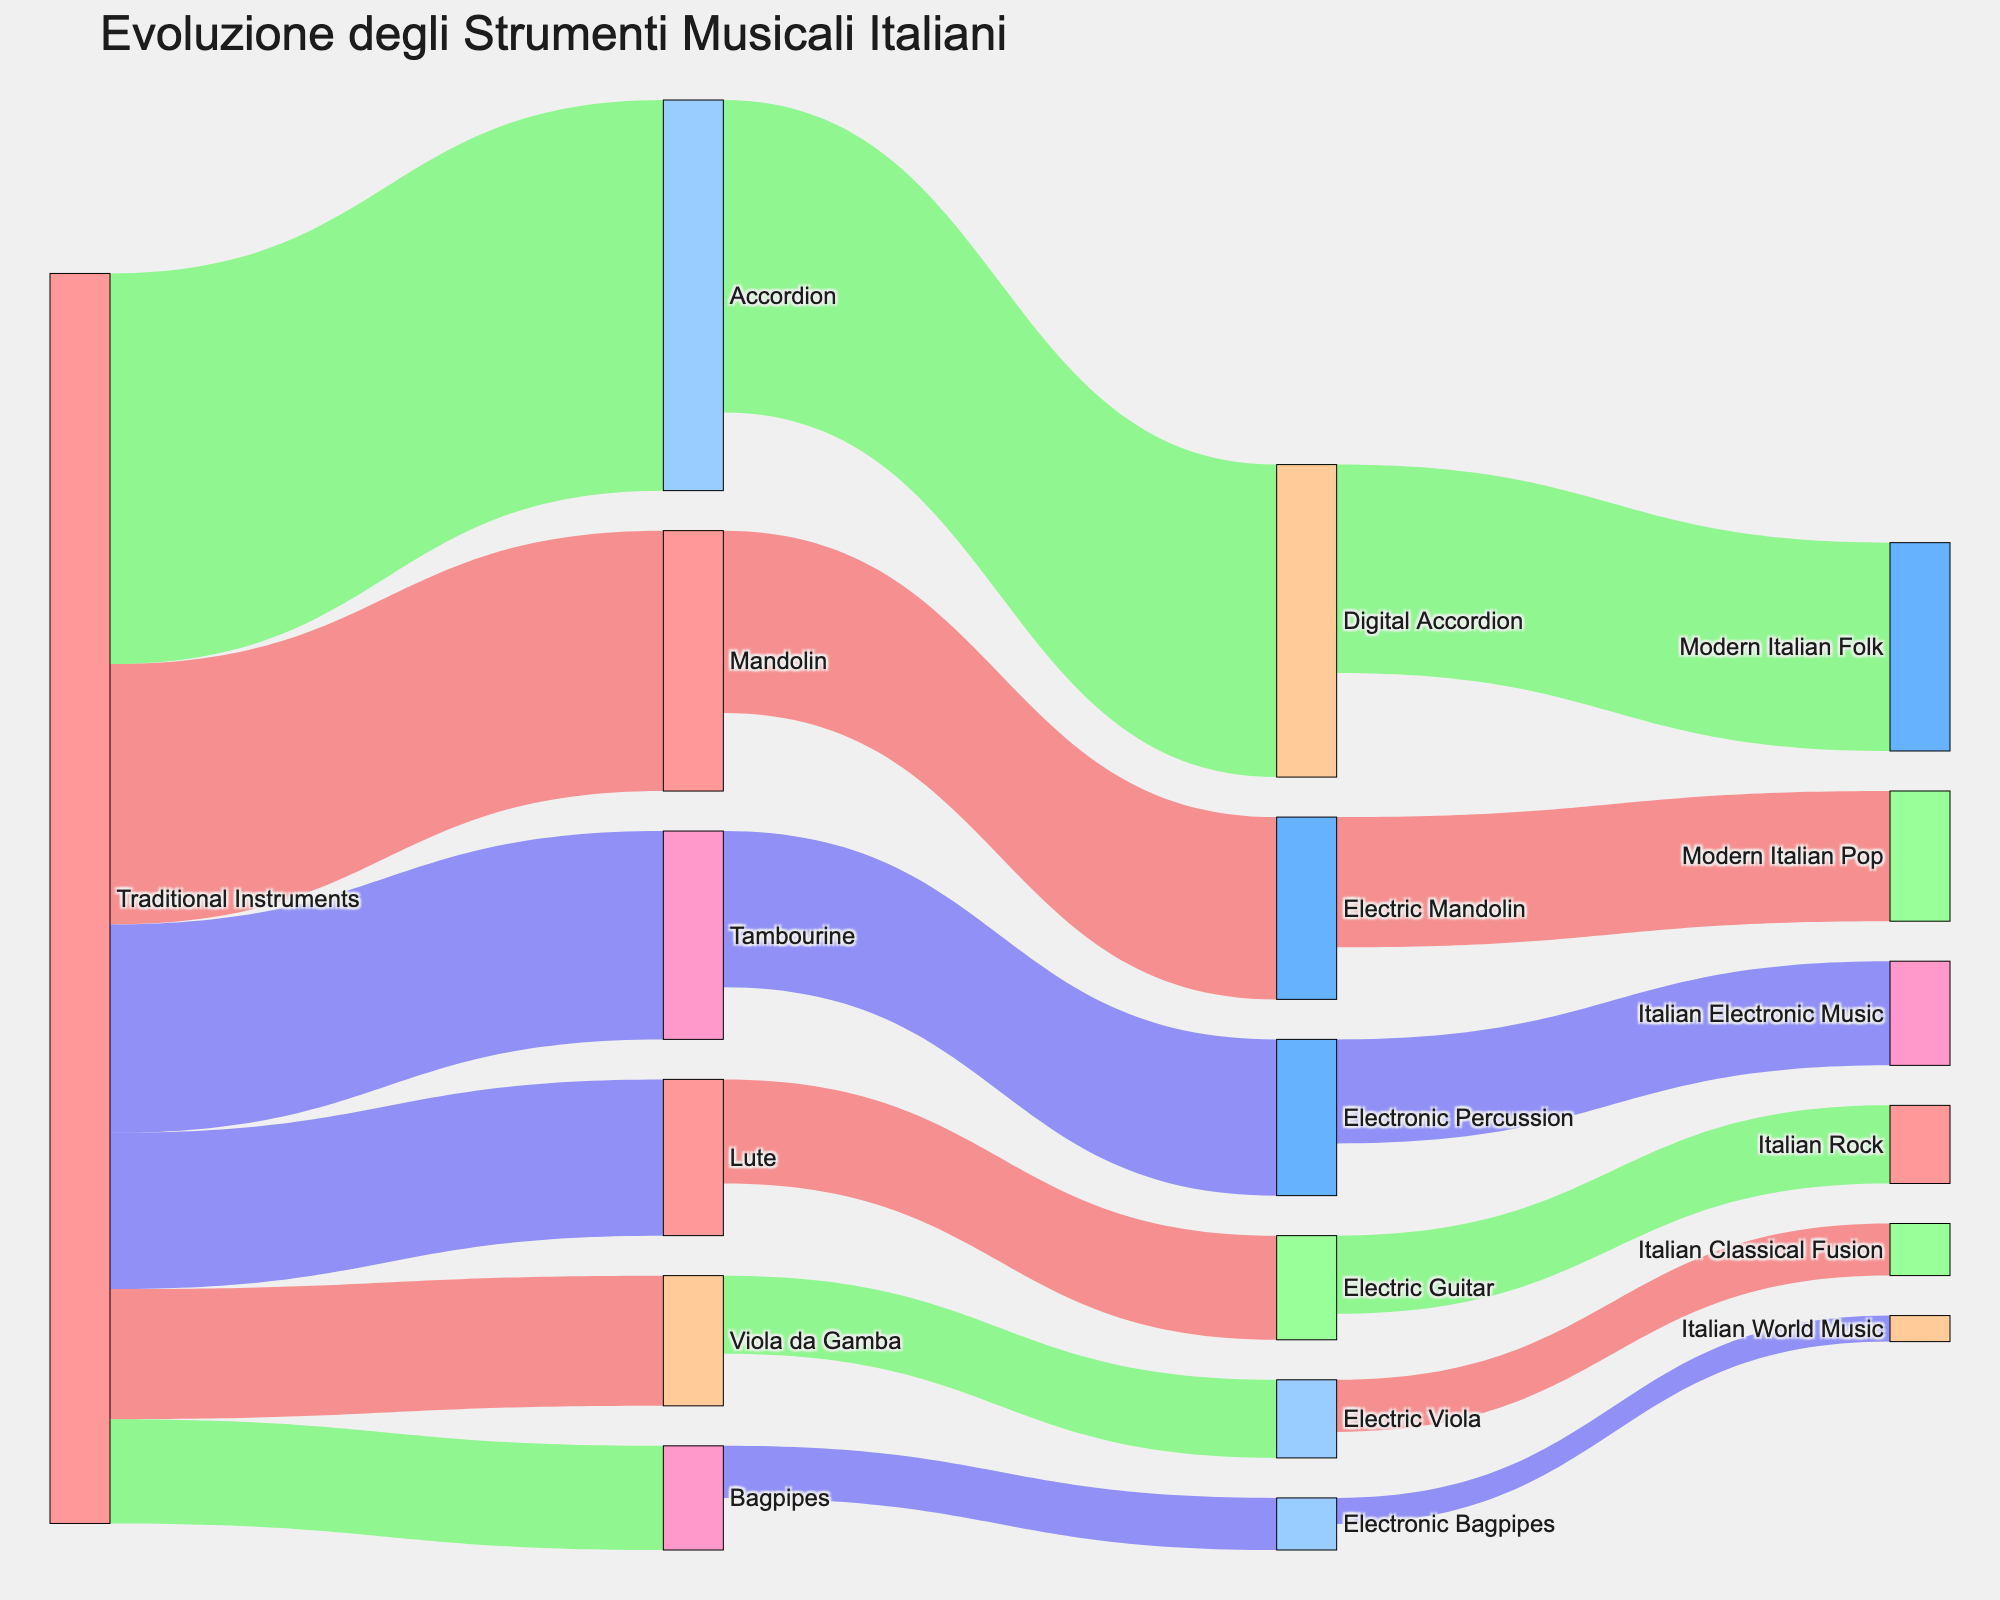What is the title of the figure? The title of the figure is typically found at the top of the visualization and is prominently displayed in larger text than other parts of the plot. By looking at the top of the Sankey Diagram, we can find the specific name given.
Answer: Evoluzione degli Strumenti Musicali Italiani How many connections originate from Traditional Instruments? To find out how many connections come from Traditional Instruments, we count the lines that start from the Traditional Instruments node. Specifically, we look for the lines linking Traditional Instruments to other nodes directly.
Answer: 6 Which modern instrument category receives the most connections and how many? By observing the terminal nodes in the diagram, we look for the modern instrument with the most incoming connections. We count the lines leading toward each modern instrument and identify which node has the highest count.
Answer: Modern Italian Folk, 8 Compare the values flowing from Mandolin to Electric Mandolin and Accordion to Digital Accordion. Which connection has a higher value? Examine the values of the connections between Mandolin to Electric Mandolin and Accordion to Digital Accordion by looking at the numeric values displayed on the Sankey Diagram. Then compare these two numbers to determine which is higher.
Answer: Accordion to Digital Accordion What's the total value of connections leading from Traditional Instruments to modern musical genres? First, identify the connections that flow from Traditional Instruments to modern musical genres (i.e., from the transformed intermediate instruments). Then, sum up the values of these connections to find the total value.
Answer: 29 How many different instruments does the node Traditional Instruments split into? Count the number of different lines or connections starting from the Traditional Instruments node that lead to other distinct nodes in the Sankey Diagram.
Answer: 6 Which instrument has the least value flowing toward modern genres, and what is that value? Identify each connection leading to modern genres and compare their values. The smallest numeric value indicates the least value flowing from an instrument toward a modern genre.
Answer: Electronic Bagpipes, 1 What's the sum of all values that flow into Italian Classical Fusion? Find all the connections leading to the Italian Classical Fusion node and sum their values to get the total amount flowing into that node.
Answer: 2 If you combine the values flowing from Lute to Electric Guitar and from Electric Guitar to Italian Rock, what's the total? First, find the value of the connection from Lute to Electric Guitar and then the value from Electric Guitar to Italian Rock. Add these two values together to get the total sum.
Answer: 7 Which traditional instrument has the highest number of transformations into modern instruments, and what are those transformations? Identify each traditional instrument and count how many connections they have leading to modern instruments. The instrument with the highest count is the answer. Then list the corresponding transformations.
Answer: Accordion, Digital Accordion -> Modern Italian Folk 